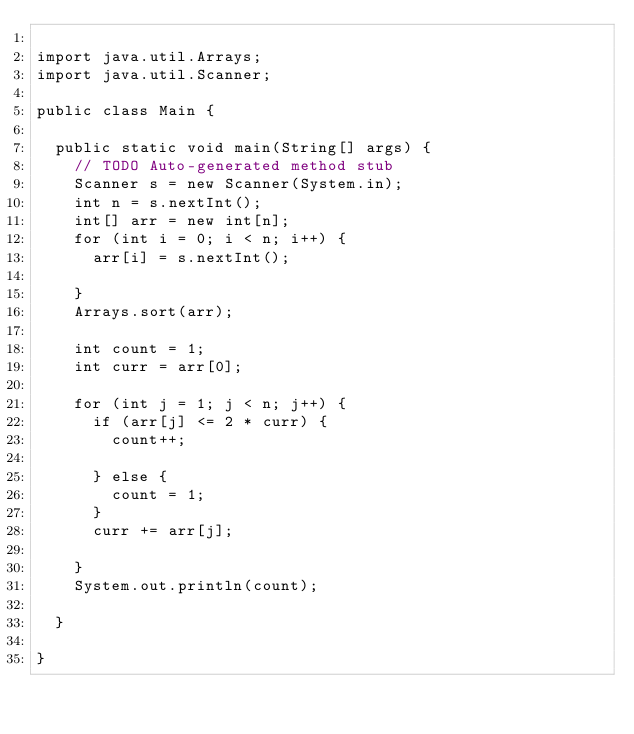Convert code to text. <code><loc_0><loc_0><loc_500><loc_500><_Java_>
import java.util.Arrays;
import java.util.Scanner;

public class Main {

	public static void main(String[] args) {
		// TODO Auto-generated method stub
		Scanner s = new Scanner(System.in);
		int n = s.nextInt();
		int[] arr = new int[n];
		for (int i = 0; i < n; i++) {
			arr[i] = s.nextInt();

		}
		Arrays.sort(arr);

		int count = 1;
		int curr = arr[0];
	
		for (int j = 1; j < n; j++) {
			if (arr[j] <= 2 * curr) {
				count++;

			} else {
				count = 1;
			}
			curr += arr[j];

		}
		System.out.println(count);

	}

}</code> 